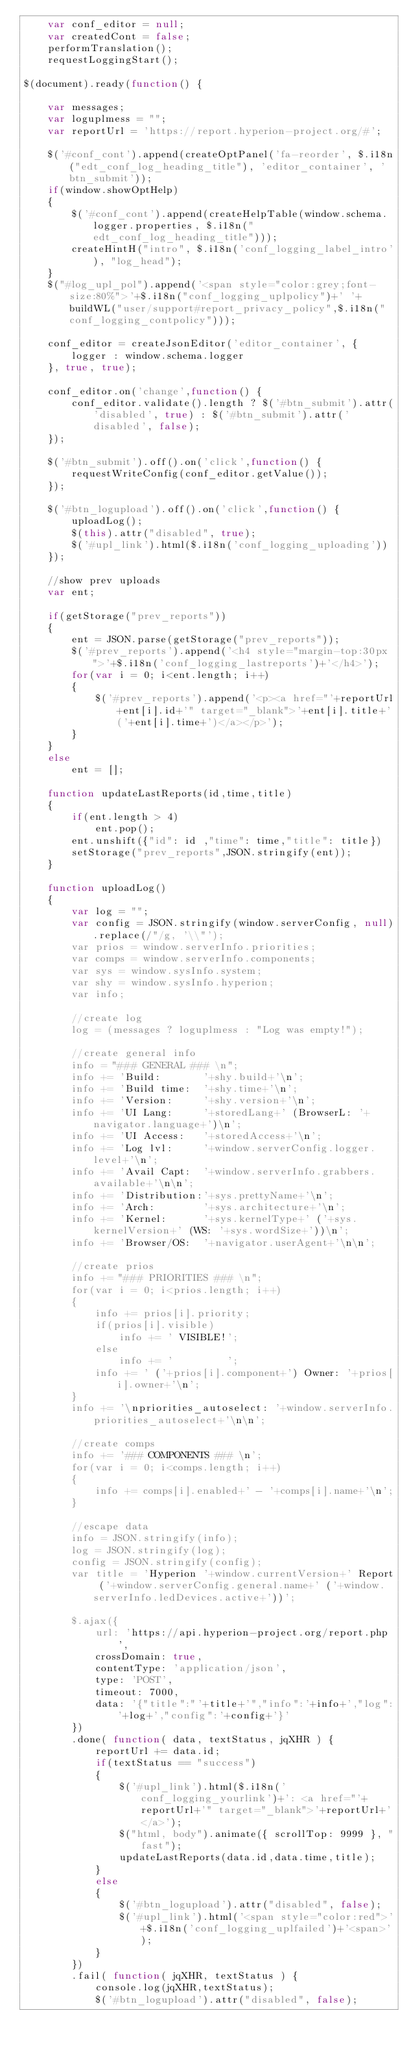Convert code to text. <code><loc_0><loc_0><loc_500><loc_500><_JavaScript_>	var conf_editor = null;
	var createdCont = false;
	performTranslation();
	requestLoggingStart();

$(document).ready(function() {
	
	var messages;
	var loguplmess = "";
	var reportUrl = 'https://report.hyperion-project.org/#';
	
	$('#conf_cont').append(createOptPanel('fa-reorder', $.i18n("edt_conf_log_heading_title"), 'editor_container', 'btn_submit'));
	if(window.showOptHelp)
	{
		$('#conf_cont').append(createHelpTable(window.schema.logger.properties, $.i18n("edt_conf_log_heading_title")));
		createHintH("intro", $.i18n('conf_logging_label_intro'), "log_head");
	}
	$("#log_upl_pol").append('<span style="color:grey;font-size:80%">'+$.i18n("conf_logging_uplpolicy")+' '+buildWL("user/support#report_privacy_policy",$.i18n("conf_logging_contpolicy")));
	
	conf_editor = createJsonEditor('editor_container', {
		logger : window.schema.logger
	}, true, true);
	
	conf_editor.on('change',function() {
		conf_editor.validate().length ? $('#btn_submit').attr('disabled', true) : $('#btn_submit').attr('disabled', false);
	});
	
	$('#btn_submit').off().on('click',function() {
		requestWriteConfig(conf_editor.getValue());
	});

	$('#btn_logupload').off().on('click',function() {
		uploadLog();
		$(this).attr("disabled", true);
		$('#upl_link').html($.i18n('conf_logging_uploading'))
	});
	
	//show prev uploads
	var ent;

	if(getStorage("prev_reports"))
	{
		ent = JSON.parse(getStorage("prev_reports"));
		$('#prev_reports').append('<h4 style="margin-top:30px">'+$.i18n('conf_logging_lastreports')+'</h4>');
		for(var i = 0; i<ent.length; i++)
		{
			$('#prev_reports').append('<p><a href="'+reportUrl+ent[i].id+'" target="_blank">'+ent[i].title+'('+ent[i].time+')</a></p>');
		}
	}
	else
		ent = [];
	
	function updateLastReports(id,time,title)
	{
		if(ent.length > 4)
			ent.pop();
		ent.unshift({"id": id ,"time": time,"title": title})
		setStorage("prev_reports",JSON.stringify(ent));
	}
	
	function uploadLog()
	{
		var log = "";
		var config = JSON.stringify(window.serverConfig, null).replace(/"/g, '\\"');
		var prios = window.serverInfo.priorities;
		var comps = window.serverInfo.components;
		var sys = window.sysInfo.system;
		var shy = window.sysInfo.hyperion;
		var info;
		
		//create log
		log = (messages ? loguplmess : "Log was empty!");

		//create general info
		info = "### GENERAL ### \n";
		info += 'Build:       '+shy.build+'\n';
		info += 'Build time:  '+shy.time+'\n';
		info += 'Version:     '+shy.version+'\n';
		info += 'UI Lang:     '+storedLang+' (BrowserL: '+navigator.language+')\n';
		info += 'UI Access:   '+storedAccess+'\n';
		info += 'Log lvl:     '+window.serverConfig.logger.level+'\n';
		info += 'Avail Capt:  '+window.serverInfo.grabbers.available+'\n\n';
		info += 'Distribution:'+sys.prettyName+'\n';
		info += 'Arch:        '+sys.architecture+'\n';
		info += 'Kernel:      '+sys.kernelType+' ('+sys.kernelVersion+' (WS: '+sys.wordSize+'))\n';
		info += 'Browser/OS:  '+navigator.userAgent+'\n\n';
		
		//create prios
		info += "### PRIORITIES ### \n";
		for(var i = 0; i<prios.length; i++)
		{
			info += prios[i].priority;
			if(prios[i].visible)
				info += ' VISIBLE!';
			else
				info += '         ';
			info += ' ('+prios[i].component+') Owner: '+prios[i].owner+'\n';
		}
		info += '\npriorities_autoselect: '+window.serverInfo.priorities_autoselect+'\n\n';
		
		//create comps
		info += '### COMPONENTS ### \n';
		for(var i = 0; i<comps.length; i++)
		{
			info += comps[i].enabled+' - '+comps[i].name+'\n';
		}
		
		//escape data
		info = JSON.stringify(info);
		log = JSON.stringify(log);
		config = JSON.stringify(config);
		var title = 'Hyperion '+window.currentVersion+' Report ('+window.serverConfig.general.name+' ('+window.serverInfo.ledDevices.active+'))';

		$.ajax({
			url: 'https://api.hyperion-project.org/report.php',
			crossDomain: true,
			contentType: 'application/json',
			type: 'POST',
			timeout: 7000,
			data: '{"title":"'+title+'","info":'+info+',"log":'+log+',"config":'+config+'}'
		})
		.done( function( data, textStatus, jqXHR ) {
			reportUrl += data.id;
			if(textStatus == "success")
			{
				$('#upl_link').html($.i18n('conf_logging_yourlink')+': <a href="'+reportUrl+'" target="_blank">'+reportUrl+'</a>');
				$("html, body").animate({ scrollTop: 9999 }, "fast");
				updateLastReports(data.id,data.time,title);
			}
			else
			{
				$('#btn_logupload').attr("disabled", false);
				$('#upl_link').html('<span style="color:red">'+$.i18n('conf_logging_uplfailed')+'<span>');
			}
		})
		.fail( function( jqXHR, textStatus ) {
			console.log(jqXHR,textStatus);
			$('#btn_logupload').attr("disabled", false);</code> 